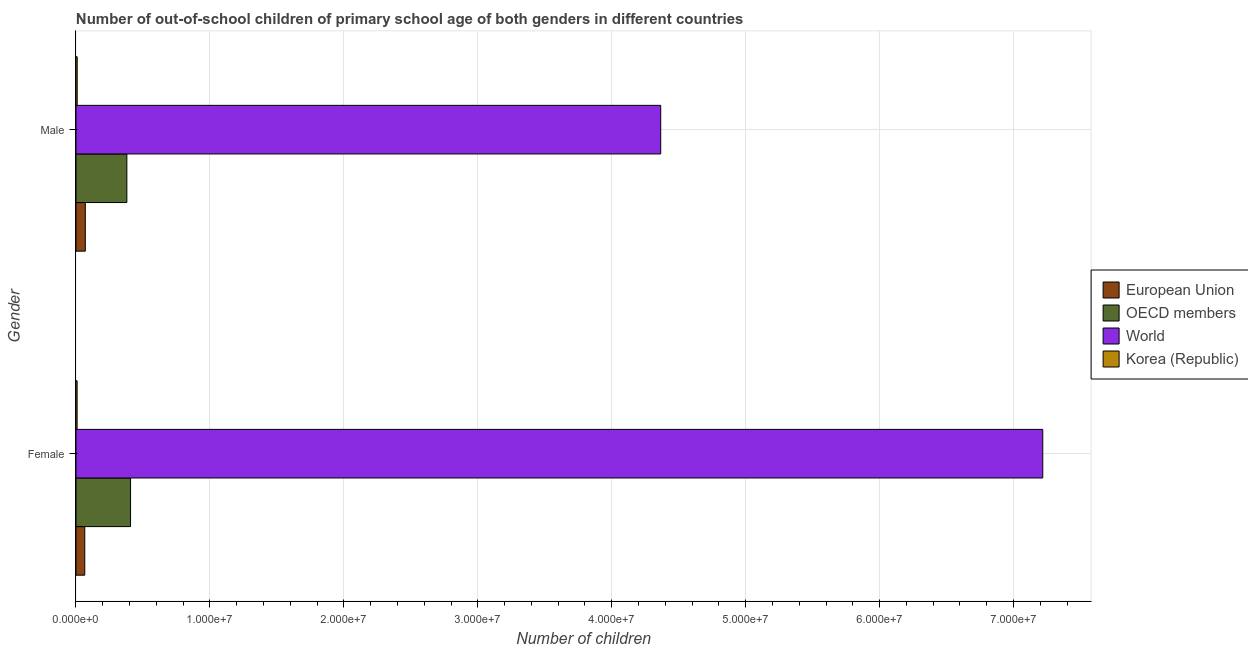How many different coloured bars are there?
Ensure brevity in your answer.  4. How many groups of bars are there?
Ensure brevity in your answer.  2. What is the label of the 1st group of bars from the top?
Your answer should be very brief. Male. What is the number of male out-of-school students in World?
Offer a very short reply. 4.37e+07. Across all countries, what is the maximum number of male out-of-school students?
Offer a very short reply. 4.37e+07. Across all countries, what is the minimum number of male out-of-school students?
Make the answer very short. 9.05e+04. In which country was the number of male out-of-school students maximum?
Ensure brevity in your answer.  World. In which country was the number of female out-of-school students minimum?
Keep it short and to the point. Korea (Republic). What is the total number of female out-of-school students in the graph?
Your answer should be compact. 7.70e+07. What is the difference between the number of male out-of-school students in World and that in OECD members?
Provide a short and direct response. 3.99e+07. What is the difference between the number of female out-of-school students in European Union and the number of male out-of-school students in OECD members?
Provide a succinct answer. -3.14e+06. What is the average number of female out-of-school students per country?
Keep it short and to the point. 1.92e+07. What is the difference between the number of female out-of-school students and number of male out-of-school students in Korea (Republic)?
Give a very brief answer. -5290. In how many countries, is the number of female out-of-school students greater than 36000000 ?
Your answer should be compact. 1. What is the ratio of the number of female out-of-school students in World to that in OECD members?
Your answer should be compact. 17.72. How many bars are there?
Offer a terse response. 8. Are all the bars in the graph horizontal?
Your answer should be compact. Yes. How many countries are there in the graph?
Keep it short and to the point. 4. Does the graph contain grids?
Your response must be concise. Yes. How many legend labels are there?
Ensure brevity in your answer.  4. How are the legend labels stacked?
Provide a short and direct response. Vertical. What is the title of the graph?
Offer a terse response. Number of out-of-school children of primary school age of both genders in different countries. What is the label or title of the X-axis?
Offer a terse response. Number of children. What is the Number of children in European Union in Female?
Offer a terse response. 6.56e+05. What is the Number of children in OECD members in Female?
Your answer should be compact. 4.07e+06. What is the Number of children in World in Female?
Keep it short and to the point. 7.22e+07. What is the Number of children in Korea (Republic) in Female?
Make the answer very short. 8.52e+04. What is the Number of children of European Union in Male?
Give a very brief answer. 6.96e+05. What is the Number of children in OECD members in Male?
Provide a succinct answer. 3.80e+06. What is the Number of children of World in Male?
Give a very brief answer. 4.37e+07. What is the Number of children in Korea (Republic) in Male?
Keep it short and to the point. 9.05e+04. Across all Gender, what is the maximum Number of children of European Union?
Keep it short and to the point. 6.96e+05. Across all Gender, what is the maximum Number of children in OECD members?
Offer a very short reply. 4.07e+06. Across all Gender, what is the maximum Number of children in World?
Make the answer very short. 7.22e+07. Across all Gender, what is the maximum Number of children in Korea (Republic)?
Make the answer very short. 9.05e+04. Across all Gender, what is the minimum Number of children of European Union?
Provide a short and direct response. 6.56e+05. Across all Gender, what is the minimum Number of children of OECD members?
Provide a short and direct response. 3.80e+06. Across all Gender, what is the minimum Number of children in World?
Your response must be concise. 4.37e+07. Across all Gender, what is the minimum Number of children of Korea (Republic)?
Your response must be concise. 8.52e+04. What is the total Number of children in European Union in the graph?
Keep it short and to the point. 1.35e+06. What is the total Number of children of OECD members in the graph?
Offer a terse response. 7.87e+06. What is the total Number of children in World in the graph?
Offer a terse response. 1.16e+08. What is the total Number of children of Korea (Republic) in the graph?
Give a very brief answer. 1.76e+05. What is the difference between the Number of children of European Union in Female and that in Male?
Your answer should be very brief. -4.01e+04. What is the difference between the Number of children in OECD members in Female and that in Male?
Make the answer very short. 2.76e+05. What is the difference between the Number of children in World in Female and that in Male?
Offer a very short reply. 2.85e+07. What is the difference between the Number of children in Korea (Republic) in Female and that in Male?
Ensure brevity in your answer.  -5290. What is the difference between the Number of children of European Union in Female and the Number of children of OECD members in Male?
Your answer should be very brief. -3.14e+06. What is the difference between the Number of children of European Union in Female and the Number of children of World in Male?
Your answer should be compact. -4.30e+07. What is the difference between the Number of children in European Union in Female and the Number of children in Korea (Republic) in Male?
Your answer should be compact. 5.65e+05. What is the difference between the Number of children of OECD members in Female and the Number of children of World in Male?
Your answer should be very brief. -3.96e+07. What is the difference between the Number of children of OECD members in Female and the Number of children of Korea (Republic) in Male?
Your answer should be very brief. 3.98e+06. What is the difference between the Number of children of World in Female and the Number of children of Korea (Republic) in Male?
Provide a succinct answer. 7.21e+07. What is the average Number of children in European Union per Gender?
Provide a short and direct response. 6.76e+05. What is the average Number of children of OECD members per Gender?
Offer a terse response. 3.94e+06. What is the average Number of children in World per Gender?
Your response must be concise. 5.79e+07. What is the average Number of children in Korea (Republic) per Gender?
Provide a succinct answer. 8.79e+04. What is the difference between the Number of children of European Union and Number of children of OECD members in Female?
Provide a succinct answer. -3.42e+06. What is the difference between the Number of children of European Union and Number of children of World in Female?
Give a very brief answer. -7.15e+07. What is the difference between the Number of children in European Union and Number of children in Korea (Republic) in Female?
Your answer should be compact. 5.70e+05. What is the difference between the Number of children of OECD members and Number of children of World in Female?
Give a very brief answer. -6.81e+07. What is the difference between the Number of children of OECD members and Number of children of Korea (Republic) in Female?
Offer a very short reply. 3.99e+06. What is the difference between the Number of children in World and Number of children in Korea (Republic) in Female?
Offer a terse response. 7.21e+07. What is the difference between the Number of children of European Union and Number of children of OECD members in Male?
Ensure brevity in your answer.  -3.10e+06. What is the difference between the Number of children of European Union and Number of children of World in Male?
Provide a short and direct response. -4.30e+07. What is the difference between the Number of children in European Union and Number of children in Korea (Republic) in Male?
Offer a terse response. 6.05e+05. What is the difference between the Number of children in OECD members and Number of children in World in Male?
Provide a short and direct response. -3.99e+07. What is the difference between the Number of children in OECD members and Number of children in Korea (Republic) in Male?
Keep it short and to the point. 3.71e+06. What is the difference between the Number of children of World and Number of children of Korea (Republic) in Male?
Your response must be concise. 4.36e+07. What is the ratio of the Number of children of European Union in Female to that in Male?
Provide a short and direct response. 0.94. What is the ratio of the Number of children in OECD members in Female to that in Male?
Provide a succinct answer. 1.07. What is the ratio of the Number of children in World in Female to that in Male?
Offer a terse response. 1.65. What is the ratio of the Number of children of Korea (Republic) in Female to that in Male?
Offer a very short reply. 0.94. What is the difference between the highest and the second highest Number of children of European Union?
Your response must be concise. 4.01e+04. What is the difference between the highest and the second highest Number of children of OECD members?
Offer a terse response. 2.76e+05. What is the difference between the highest and the second highest Number of children of World?
Give a very brief answer. 2.85e+07. What is the difference between the highest and the second highest Number of children in Korea (Republic)?
Ensure brevity in your answer.  5290. What is the difference between the highest and the lowest Number of children of European Union?
Offer a very short reply. 4.01e+04. What is the difference between the highest and the lowest Number of children in OECD members?
Your response must be concise. 2.76e+05. What is the difference between the highest and the lowest Number of children in World?
Offer a terse response. 2.85e+07. What is the difference between the highest and the lowest Number of children of Korea (Republic)?
Keep it short and to the point. 5290. 